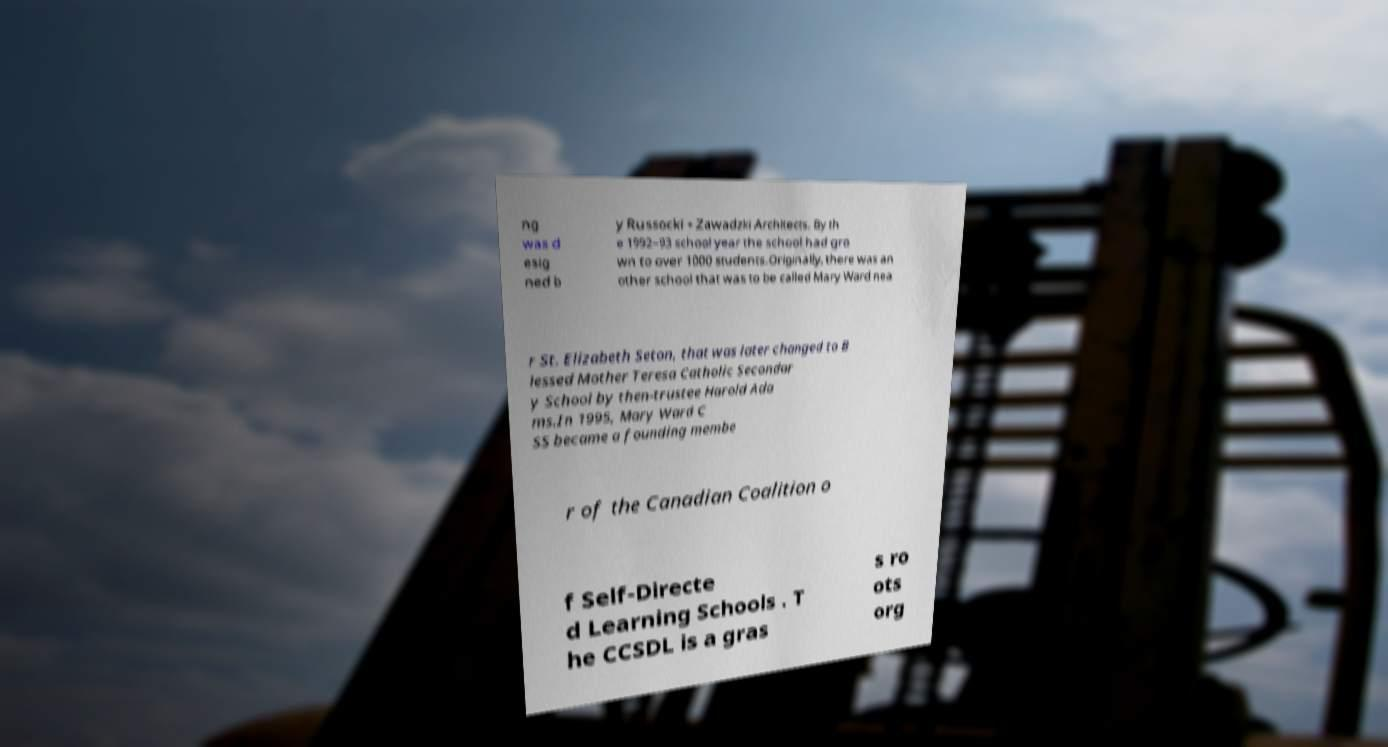What messages or text are displayed in this image? I need them in a readable, typed format. ng was d esig ned b y Russocki + Zawadzki Architects. By th e 1992–93 school year the school had gro wn to over 1000 students.Originally, there was an other school that was to be called Mary Ward nea r St. Elizabeth Seton, that was later changed to B lessed Mother Teresa Catholic Secondar y School by then-trustee Harold Ada ms.In 1995, Mary Ward C SS became a founding membe r of the Canadian Coalition o f Self-Directe d Learning Schools . T he CCSDL is a gras s ro ots org 